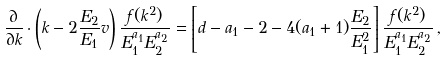<formula> <loc_0><loc_0><loc_500><loc_500>\frac { \partial } { \partial k } \cdot \left ( k - 2 \frac { E _ { 2 } } { E _ { 1 } } v \right ) \frac { f ( k ^ { 2 } ) } { E _ { 1 } ^ { a _ { 1 } } E _ { 2 } ^ { a _ { 2 } } } = \left [ d - a _ { 1 } - 2 - 4 ( a _ { 1 } + 1 ) \frac { E _ { 2 } } { E _ { 1 } ^ { 2 } } \right ] \frac { f ( k ^ { 2 } ) } { E _ { 1 } ^ { a _ { 1 } } E _ { 2 } ^ { a _ { 2 } } } \, ,</formula> 